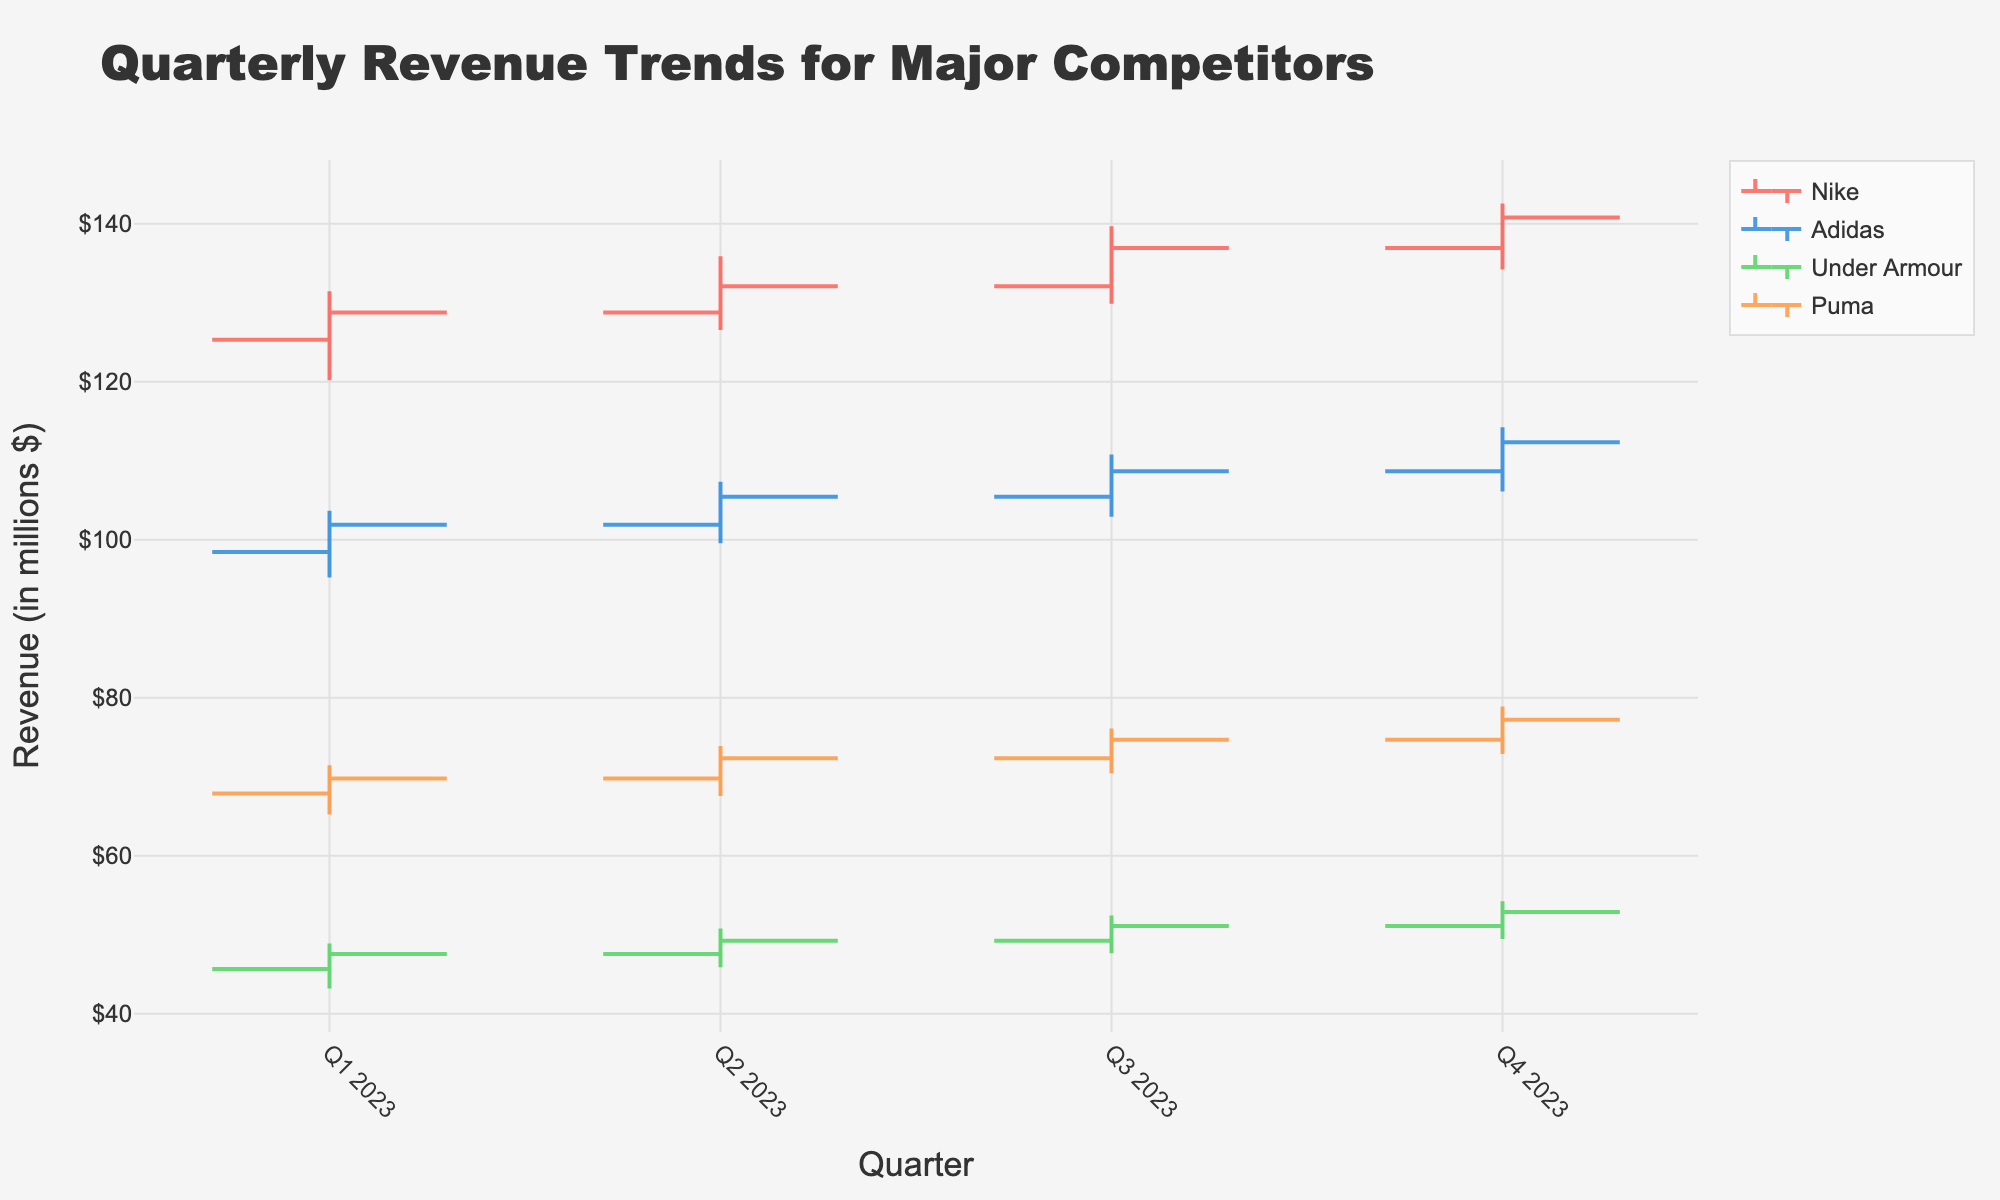What is the title of the figure? The title of the figure is often displayed prominently at the top of the graph or chart. Here, it reads "Quarterly Revenue Trends for Major Competitors".
Answer: Quarterly Revenue Trends for Major Competitors How does the revenue for Nike change from Q1 to Q2 in 2023? Looking at Nike's data from Q1 to Q2, the revenue opened at 125.32 million in Q1 and closed at 128.76 million. Then in Q2, it opened at 128.76 million and closed at 132.10 million. So the change from Q1 to Q2 shows an overall increase in revenue.
Answer: Increased Which company had the highest closing value in Q4 2023? To find the highest closing value in Q4 2023, we compare the closing values of all companies in that quarter. The closing values are: Nike: 140.78, Adidas: 112.34, Under Armour: 52.89, Puma: 77.23. Next, we identify the highest value, which is 140.78 for Nike.
Answer: Nike Between Adidas and Under Armour, which company had more consistent revenue growth over the quarters in 2023? By examining both companies' quarterly data: Adidas has a uniform increase in both opening and closing values over each quarter (Q1: 98.45 to Q4: 112.34). Under Armour also shows growth but with more fluctuations. Hence, Adidas shows more consistent growth.
Answer: Adidas What is the average closing value for Puma across all quarters in 2023? To calculate the average closing value for Puma, we sum their closing values across four quarters and divide by 4. The values are: 69.78, 72.34, 74.67, 77.23. The sum is 294.02, thus the average is 294.02 / 4 = 73.505.
Answer: 73.505 Compare the lowest values across all quarters between Nike and Adidas. Who had the lower value, and in which quarter? Comparing the lowest values for each quarter for Nike (120.18, 126.54, 129.88, 134.21) and Adidas (95.23, 99.56, 102.90, 106.12), Adidas had the lower value, which was 95.23 in Q1 2023.
Answer: Adidas in Q1 2023 What was the highest revenue value (either open, high, low, or close) for Under Armour in 2023? We examine Under Armour’s data for the highest values: Q1: 45.67, 48.90, 43.21, 47.56; Q2: 47.56, 50.78, 45.89, 49.23; Q3: 49.23, 52.45, 47.67, 51.10; Q4: 51.10, 54.23, 49.45, 52.89. The highest value is 54.23 in Q4.
Answer: 54.23 Which quarter had the smallest increase in closing values for Nike? Observing the increase in closing values for Nike in each quarter: Q1 to Q2: 128.76 to 132.10 (3.34 increase), Q2 to Q3: 132.10 to 136.92 (4.82 increase), Q3 to Q4: 136.92 to 140.78 (3.86 increase). The smallest increase is from Q1 to Q2.
Answer: Q1 to Q2 